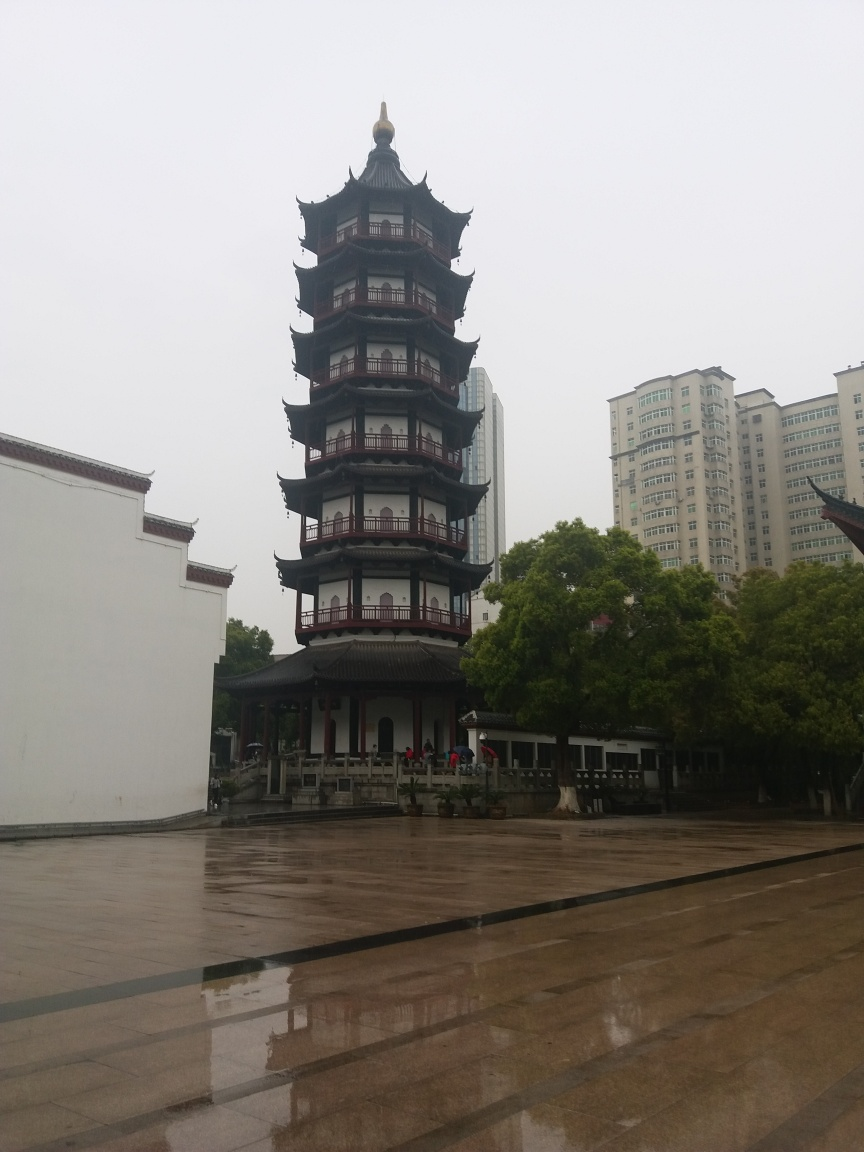What architectural style is the pagoda in the image? The pagoda in the image is indicative of a traditional East Asian style, likely Chinese, characterized by its multi-tiered eaves, upturned corners, and the prominent finial at the top. It's designed in a manner that is often associated with historical buildings found in China, suggesting it may serve as both a cultural landmark and a place of significance. 